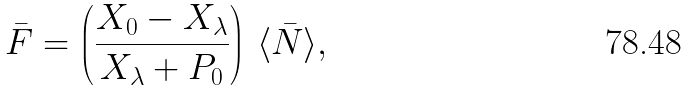Convert formula to latex. <formula><loc_0><loc_0><loc_500><loc_500>\bar { F } = \left ( \frac { X _ { 0 } - X _ { \lambda } } { X _ { \lambda } + P _ { 0 } } \right ) \, \langle \bar { N } \rangle ,</formula> 